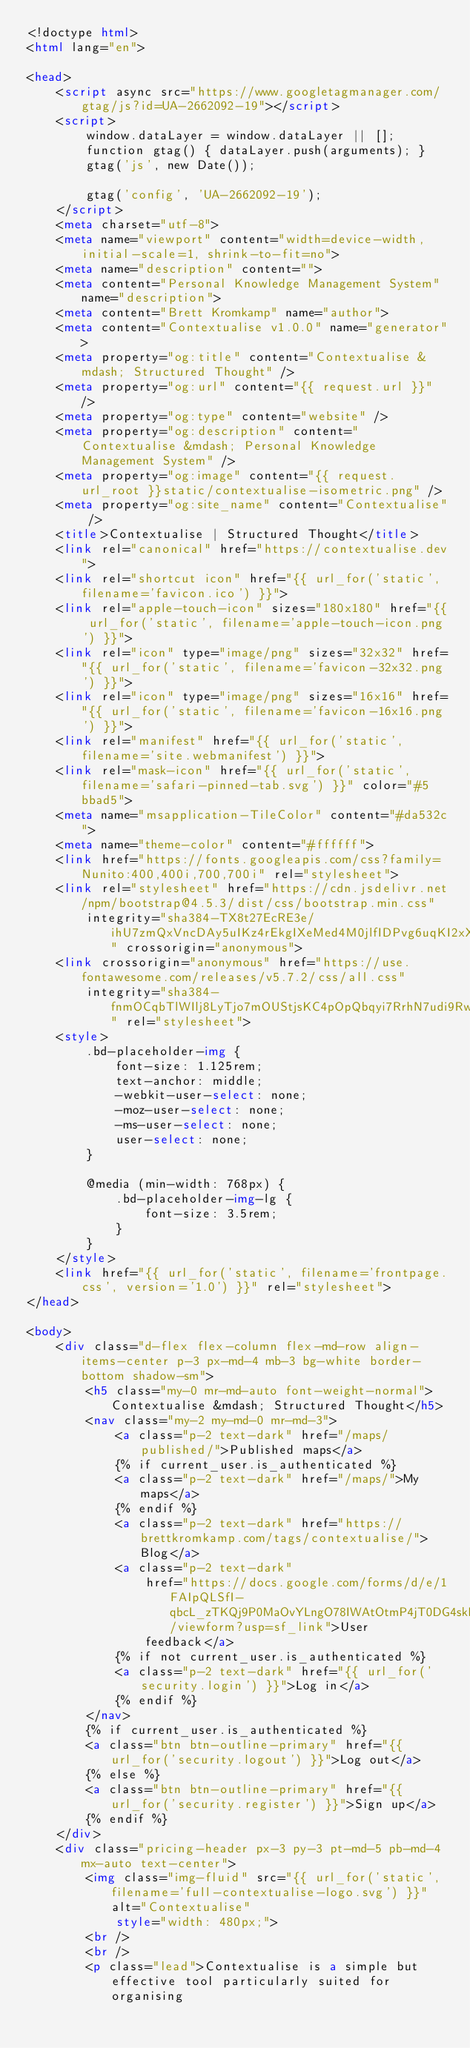<code> <loc_0><loc_0><loc_500><loc_500><_HTML_><!doctype html>
<html lang="en">

<head>
    <script async src="https://www.googletagmanager.com/gtag/js?id=UA-2662092-19"></script>
    <script>
        window.dataLayer = window.dataLayer || [];
        function gtag() { dataLayer.push(arguments); }
        gtag('js', new Date());

        gtag('config', 'UA-2662092-19');
    </script>
    <meta charset="utf-8">
    <meta name="viewport" content="width=device-width, initial-scale=1, shrink-to-fit=no">
    <meta name="description" content="">
    <meta content="Personal Knowledge Management System" name="description">
    <meta content="Brett Kromkamp" name="author">
    <meta content="Contextualise v1.0.0" name="generator">
    <meta property="og:title" content="Contextualise &mdash; Structured Thought" />
    <meta property="og:url" content="{{ request.url }}" />
    <meta property="og:type" content="website" />
    <meta property="og:description" content="Contextualise &mdash; Personal Knowledge Management System" />
    <meta property="og:image" content="{{ request.url_root }}static/contextualise-isometric.png" />
    <meta property="og:site_name" content="Contextualise" />
    <title>Contextualise | Structured Thought</title>
    <link rel="canonical" href="https://contextualise.dev">
    <link rel="shortcut icon" href="{{ url_for('static', filename='favicon.ico') }}">
    <link rel="apple-touch-icon" sizes="180x180" href="{{ url_for('static', filename='apple-touch-icon.png') }}">
    <link rel="icon" type="image/png" sizes="32x32" href="{{ url_for('static', filename='favicon-32x32.png') }}">
    <link rel="icon" type="image/png" sizes="16x16" href="{{ url_for('static', filename='favicon-16x16.png') }}">
    <link rel="manifest" href="{{ url_for('static', filename='site.webmanifest') }}">
    <link rel="mask-icon" href="{{ url_for('static', filename='safari-pinned-tab.svg') }}" color="#5bbad5">
    <meta name="msapplication-TileColor" content="#da532c">
    <meta name="theme-color" content="#ffffff">
    <link href="https://fonts.googleapis.com/css?family=Nunito:400,400i,700,700i" rel="stylesheet">
    <link rel="stylesheet" href="https://cdn.jsdelivr.net/npm/bootstrap@4.5.3/dist/css/bootstrap.min.css"
        integrity="sha384-TX8t27EcRE3e/ihU7zmQxVncDAy5uIKz4rEkgIXeMed4M0jlfIDPvg6uqKI2xXr2" crossorigin="anonymous">
    <link crossorigin="anonymous" href="https://use.fontawesome.com/releases/v5.7.2/css/all.css"
        integrity="sha384-fnmOCqbTlWIlj8LyTjo7mOUStjsKC4pOpQbqyi7RrhN7udi9RwhKkMHpvLbHG9Sr" rel="stylesheet">
    <style>
        .bd-placeholder-img {
            font-size: 1.125rem;
            text-anchor: middle;
            -webkit-user-select: none;
            -moz-user-select: none;
            -ms-user-select: none;
            user-select: none;
        }

        @media (min-width: 768px) {
            .bd-placeholder-img-lg {
                font-size: 3.5rem;
            }
        }
    </style>
    <link href="{{ url_for('static', filename='frontpage.css', version='1.0') }}" rel="stylesheet">
</head>

<body>
    <div class="d-flex flex-column flex-md-row align-items-center p-3 px-md-4 mb-3 bg-white border-bottom shadow-sm">
        <h5 class="my-0 mr-md-auto font-weight-normal">Contextualise &mdash; Structured Thought</h5>
        <nav class="my-2 my-md-0 mr-md-3">
            <a class="p-2 text-dark" href="/maps/published/">Published maps</a>
            {% if current_user.is_authenticated %}
            <a class="p-2 text-dark" href="/maps/">My maps</a>
            {% endif %}
            <a class="p-2 text-dark" href="https://brettkromkamp.com/tags/contextualise/">Blog</a>
            <a class="p-2 text-dark"
                href="https://docs.google.com/forms/d/e/1FAIpQLSfI-qbcL_zTKQj9P0MaOvYLngO78IWAtOtmP4jT0DG4skBWLg/viewform?usp=sf_link">User
                feedback</a>
            {% if not current_user.is_authenticated %}
            <a class="p-2 text-dark" href="{{ url_for('security.login') }}">Log in</a>
            {% endif %}
        </nav>
        {% if current_user.is_authenticated %}
        <a class="btn btn-outline-primary" href="{{ url_for('security.logout') }}">Log out</a>
        {% else %}
        <a class="btn btn-outline-primary" href="{{ url_for('security.register') }}">Sign up</a>
        {% endif %}
    </div>
    <div class="pricing-header px-3 py-3 pt-md-5 pb-md-4 mx-auto text-center">
        <img class="img-fluid" src="{{ url_for('static', filename='full-contextualise-logo.svg') }}" alt="Contextualise"
            style="width: 480px;">
        <br />
        <br />
        <p class="lead">Contextualise is a simple but effective tool particularly suited for organising</code> 